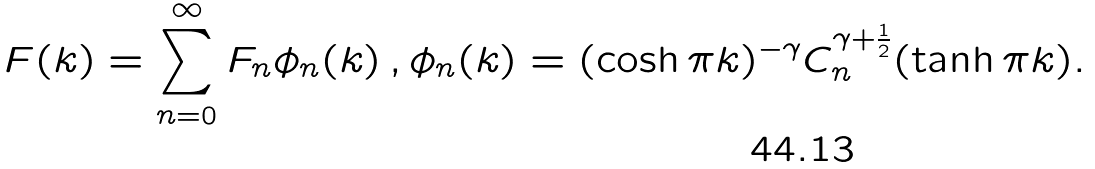Convert formula to latex. <formula><loc_0><loc_0><loc_500><loc_500>F ( k ) = \sum _ { n = 0 } ^ { \infty } F _ { n } \phi _ { n } ( k ) \, , \phi _ { n } ( k ) = ( \cosh \pi k ) ^ { - \gamma } C ^ { \gamma + \frac { 1 } { 2 } } _ { n } ( \tanh \pi k ) .</formula> 